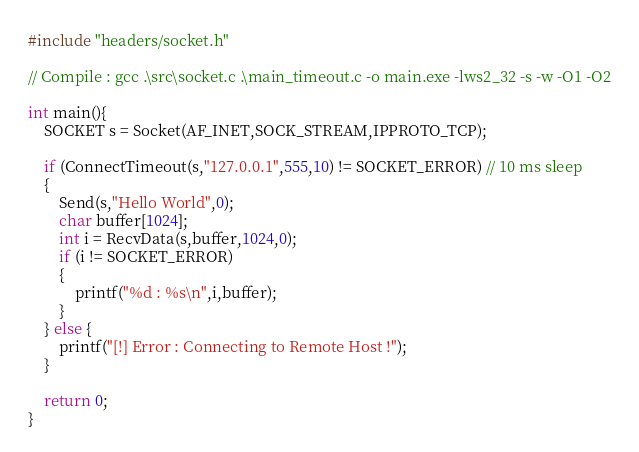<code> <loc_0><loc_0><loc_500><loc_500><_C_>#include "headers/socket.h"

// Compile : gcc .\src\socket.c .\main_timeout.c -o main.exe -lws2_32 -s -w -O1 -O2

int main(){
    SOCKET s = Socket(AF_INET,SOCK_STREAM,IPPROTO_TCP);
    
    if (ConnectTimeout(s,"127.0.0.1",555,10) != SOCKET_ERROR) // 10 ms sleep
    {
        Send(s,"Hello World",0);
        char buffer[1024];
        int i = RecvData(s,buffer,1024,0);
        if (i != SOCKET_ERROR)
        {
            printf("%d : %s\n",i,buffer);
        }
    } else {
        printf("[!] Error : Connecting to Remote Host !");
    }

    return 0;
}
</code> 